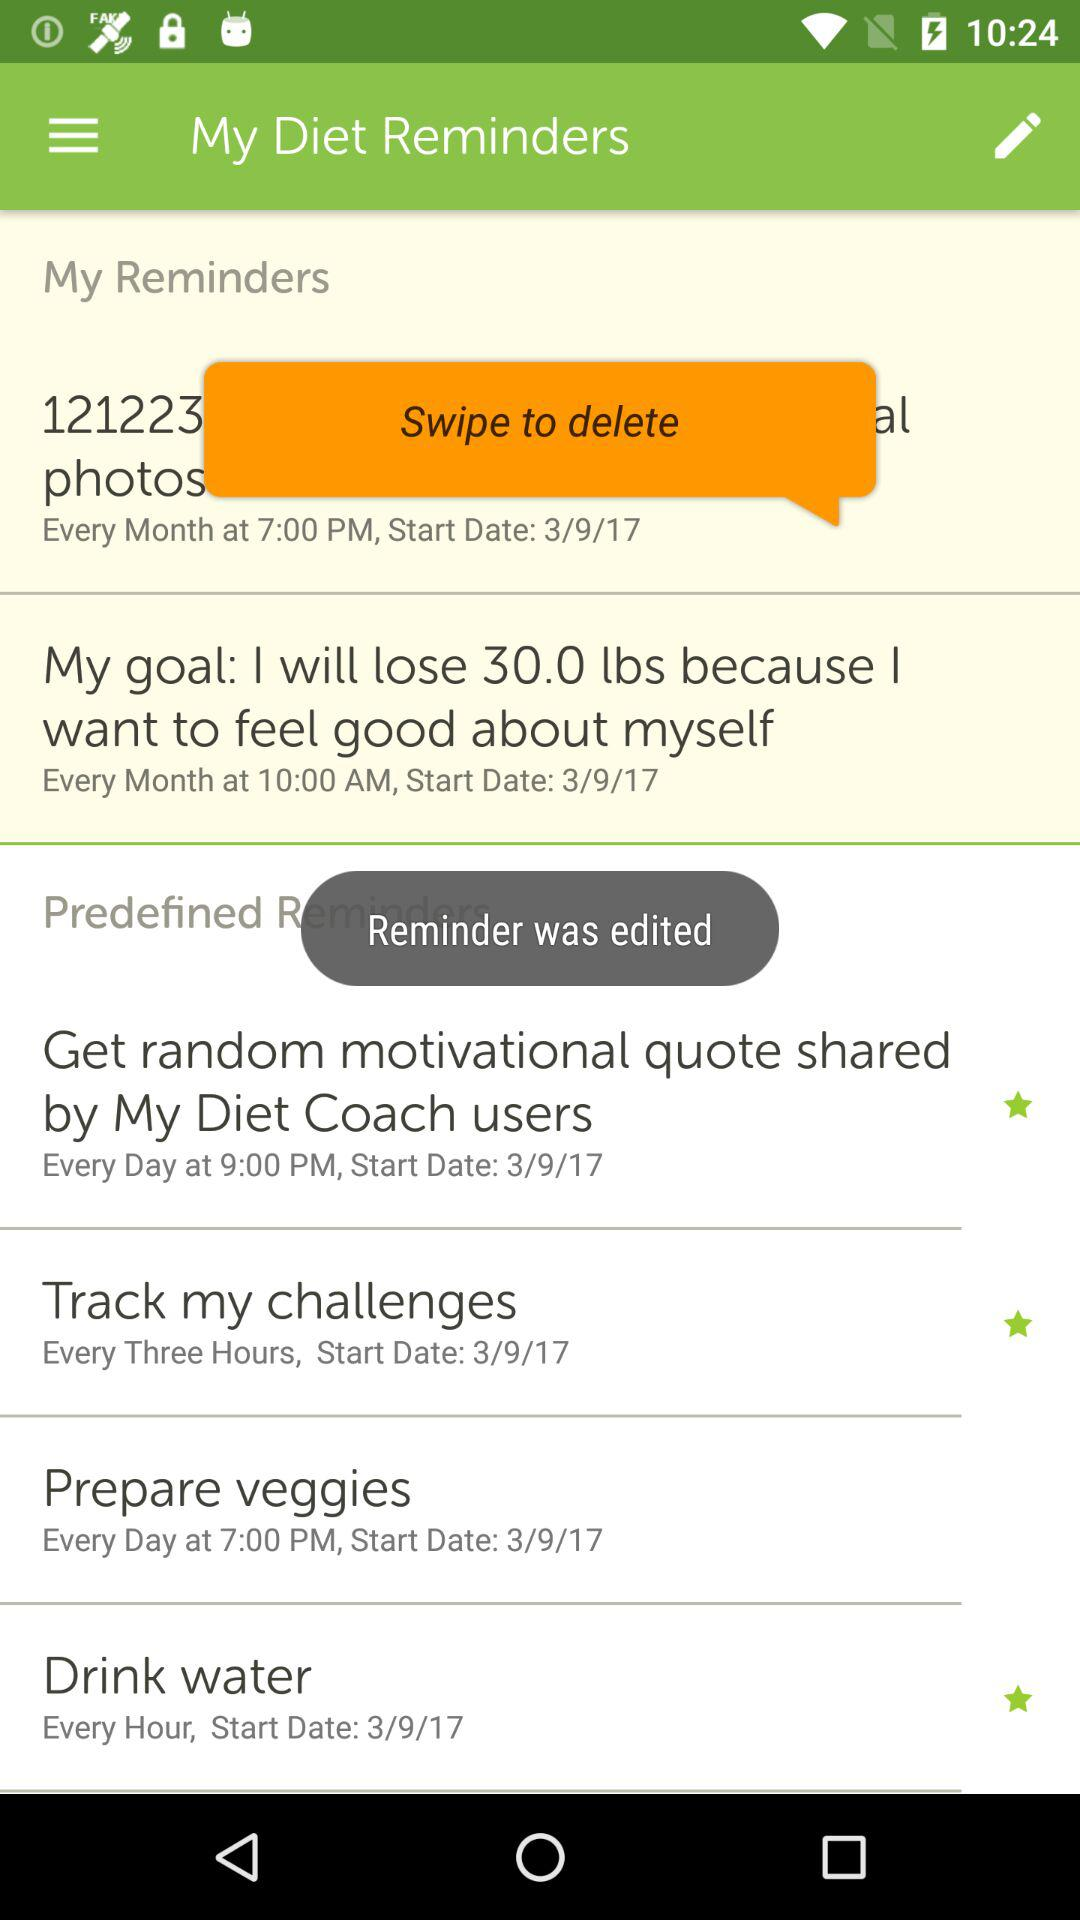How many reminders are there?
Answer the question using a single word or phrase. 6 